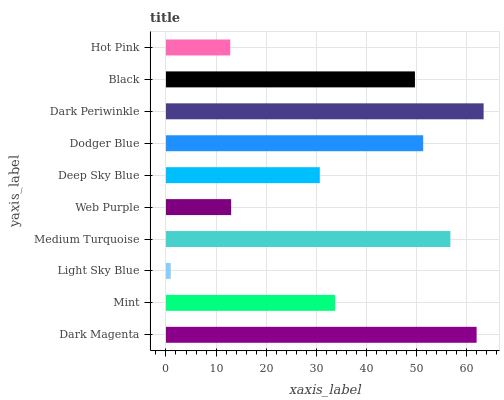Is Light Sky Blue the minimum?
Answer yes or no. Yes. Is Dark Periwinkle the maximum?
Answer yes or no. Yes. Is Mint the minimum?
Answer yes or no. No. Is Mint the maximum?
Answer yes or no. No. Is Dark Magenta greater than Mint?
Answer yes or no. Yes. Is Mint less than Dark Magenta?
Answer yes or no. Yes. Is Mint greater than Dark Magenta?
Answer yes or no. No. Is Dark Magenta less than Mint?
Answer yes or no. No. Is Black the high median?
Answer yes or no. Yes. Is Mint the low median?
Answer yes or no. Yes. Is Web Purple the high median?
Answer yes or no. No. Is Dodger Blue the low median?
Answer yes or no. No. 